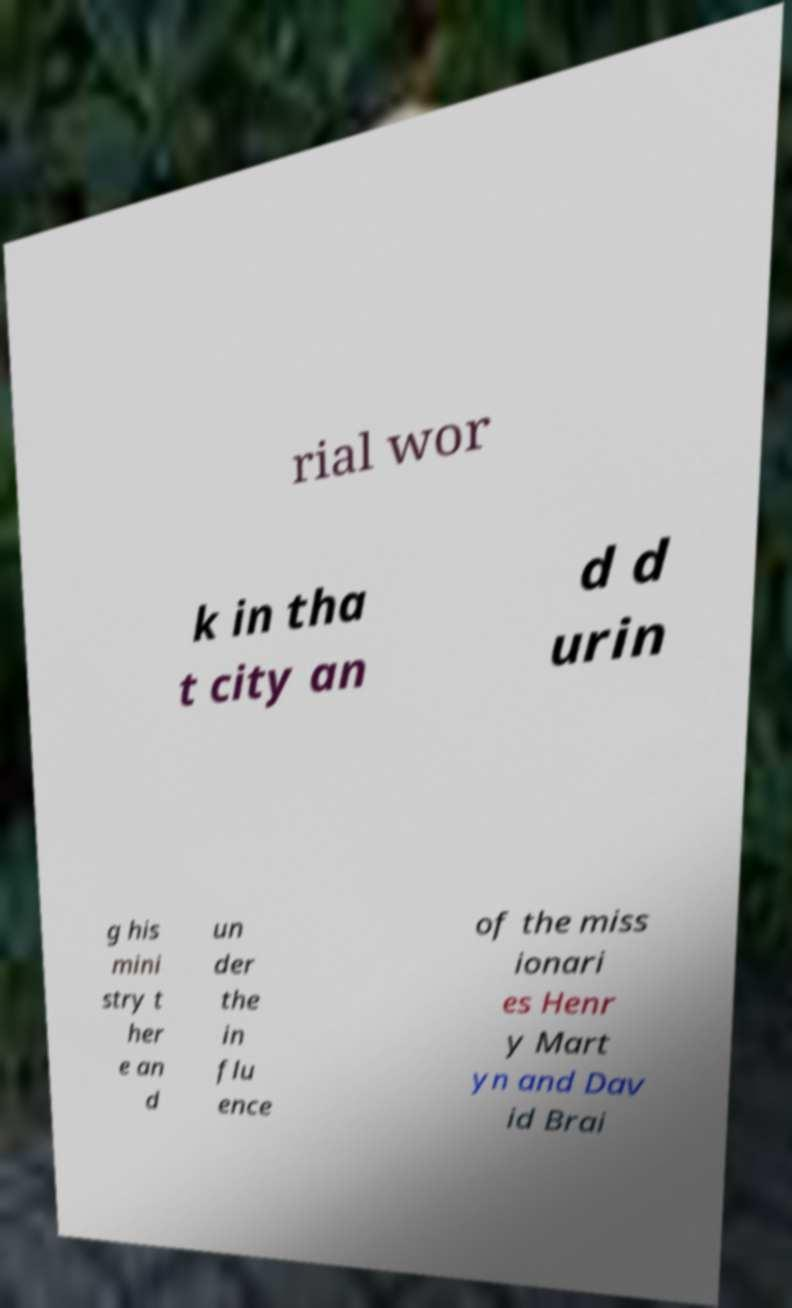Please identify and transcribe the text found in this image. rial wor k in tha t city an d d urin g his mini stry t her e an d un der the in flu ence of the miss ionari es Henr y Mart yn and Dav id Brai 